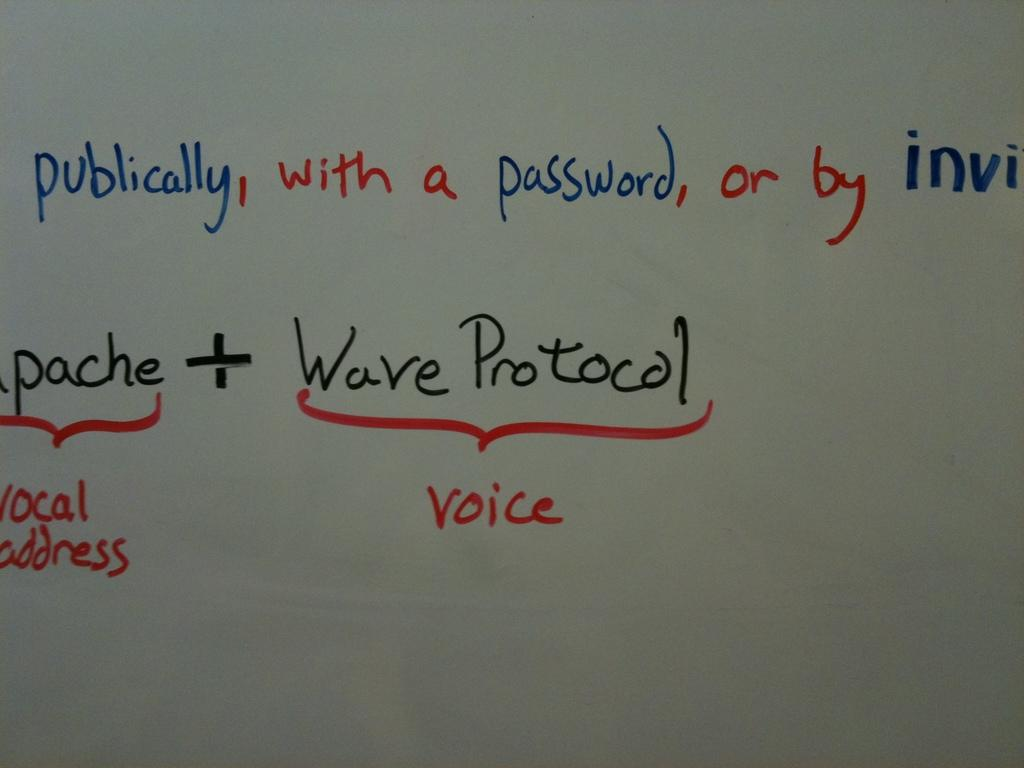<image>
Write a terse but informative summary of the picture. Writing on a white board relating to Wave Protocol with voice. 